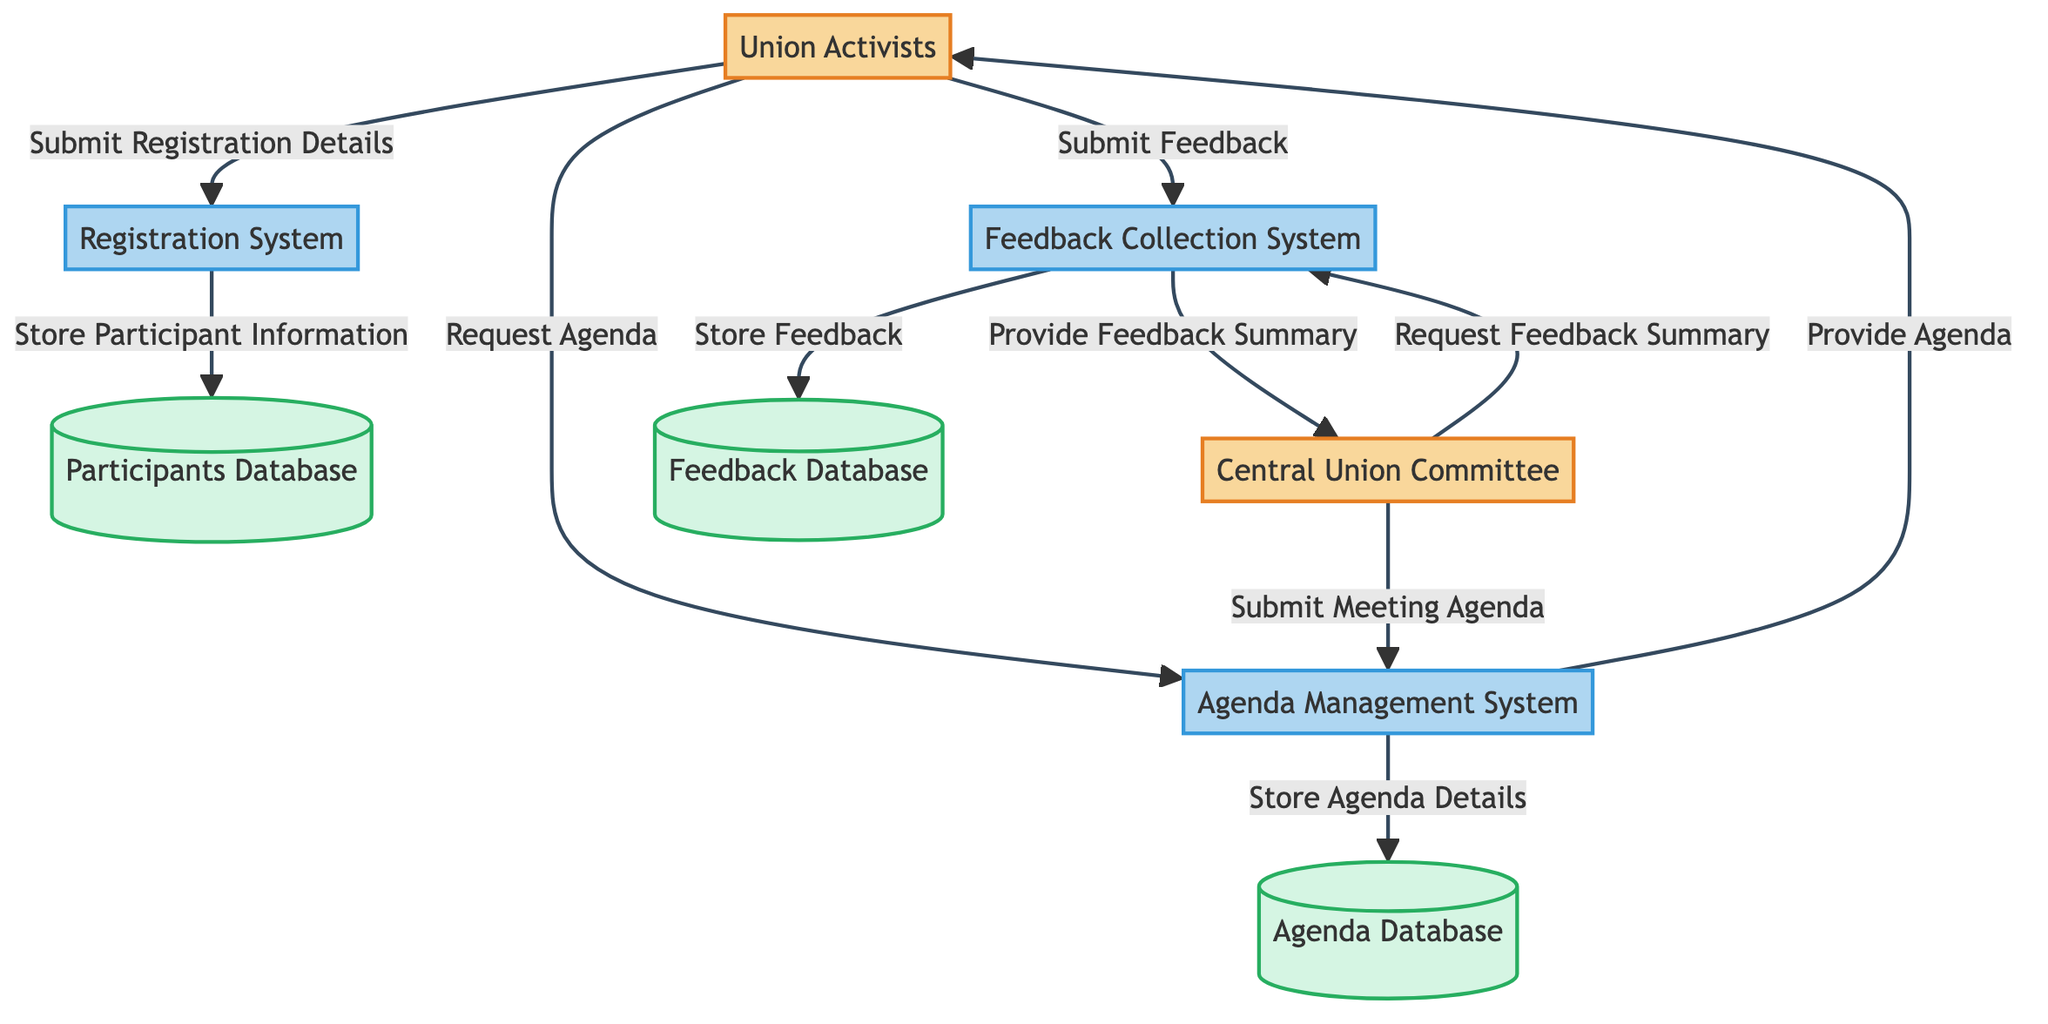What are the external entities in this diagram? The diagram shows two external entities: Union Activists and Central Union Committee. These entities represent the individuals or groups involved in the union meeting organization process.
Answer: Union Activists, Central Union Committee How many processes are represented in the diagram? There are three processes depicted in the diagram: Registration System, Agenda Management System, and Feedback Collection System. Processes are activities that handle data flow between entities and data stores.
Answer: 3 What data stores are included in the diagram? The diagram includes three data stores: Participants Database, Agenda Database, and Feedback Database. Data stores are where data is held after being processed.
Answer: Participants Database, Agenda Database, Feedback Database What is the flow from Union Activists to Registration System? The flow from Union Activists to Registration System is labeled as "Submit Registration Details," indicating that Union Activists provide their registration information to the system.
Answer: Submit Registration Details What information does the Central Union Committee provide to the Agenda Management System? The Central Union Committee submits the "Meeting Agenda" to the Agenda Management System, which is necessary for organizing the meeting’s schedule and topics.
Answer: Meeting Agenda How does the Feedback Collection System relate to the Central Union Committee? The Feedback Collection System provides a "Feedback Summary" to the Central Union Committee upon its request, thus facilitating the committee's understanding of participants' feedback after the meeting.
Answer: Provide Feedback Summary What happens to participant information in the Registration System? The Registration System stores participant information in the Participants Database, ensuring that all registered individuals are documented for the meeting.
Answer: Store Participant Information How does the Agenda Management System interact with Union Activists? The Agenda Management System interacts with Union Activists by providing the "Agenda" after they request it, ensuring that participants have access to the meeting details.
Answer: Provide Agenda What is the purpose of the Feedback Collection System? The Feedback Collection System collects and stores feedback submitted by Union Activists after the meeting, which can later be summarized and analyzed to improve future meetings.
Answer: Submit Feedback 